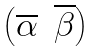<formula> <loc_0><loc_0><loc_500><loc_500>\begin{pmatrix} \overline { \alpha } & \overline { \beta } \end{pmatrix}</formula> 